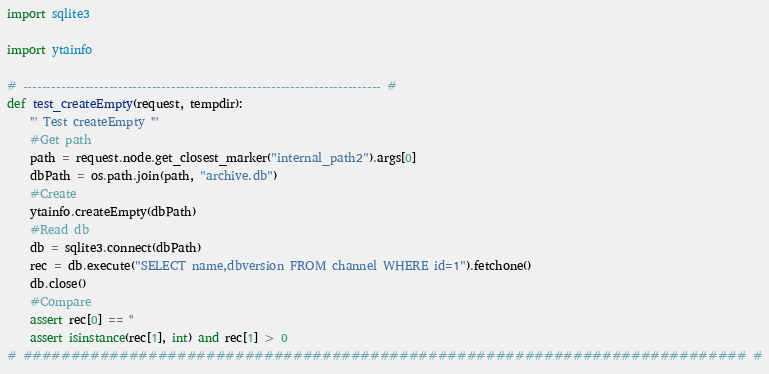<code> <loc_0><loc_0><loc_500><loc_500><_Python_>import sqlite3

import ytainfo

# --------------------------------------------------------------------------- #
def test_createEmpty(request, tempdir):
    ''' Test createEmpty '''
    #Get path
    path = request.node.get_closest_marker("internal_path2").args[0]
    dbPath = os.path.join(path, "archive.db")
    #Create
    ytainfo.createEmpty(dbPath)
    #Read db
    db = sqlite3.connect(dbPath)
    rec = db.execute("SELECT name,dbversion FROM channel WHERE id=1").fetchone()
    db.close()
    #Compare
    assert rec[0] == ''
    assert isinstance(rec[1], int) and rec[1] > 0
# ########################################################################### #
</code> 